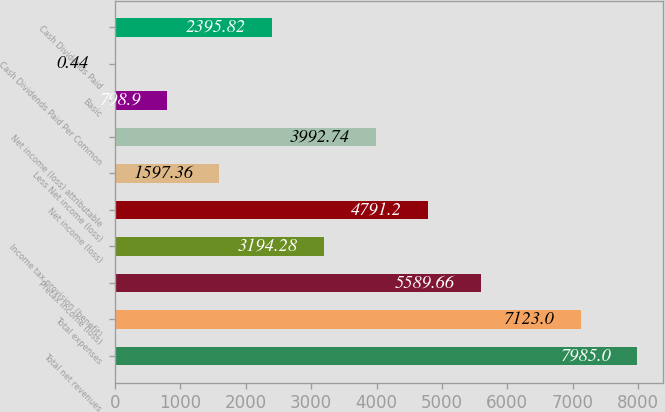<chart> <loc_0><loc_0><loc_500><loc_500><bar_chart><fcel>Total net revenues<fcel>Total expenses<fcel>Pretax income (loss)<fcel>Income tax provision (benefit)<fcel>Net income (loss)<fcel>Less Net income (loss)<fcel>Net income (loss) attributable<fcel>Basic<fcel>Cash Dividends Paid Per Common<fcel>Cash Dividends Paid<nl><fcel>7985<fcel>7123<fcel>5589.66<fcel>3194.28<fcel>4791.2<fcel>1597.36<fcel>3992.74<fcel>798.9<fcel>0.44<fcel>2395.82<nl></chart> 